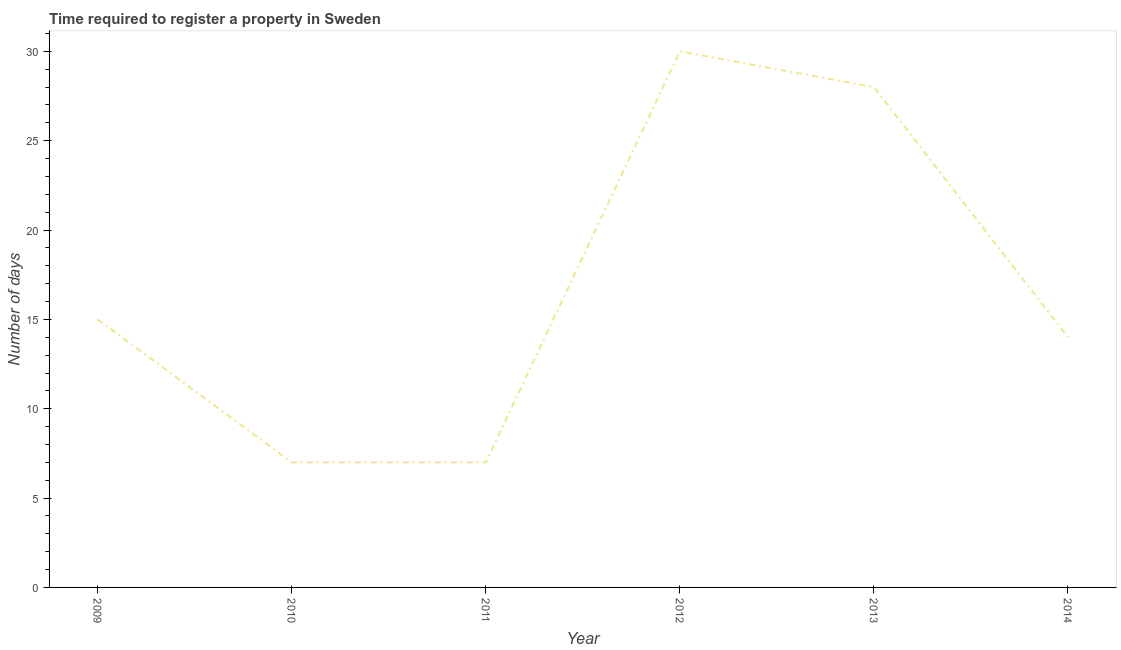What is the number of days required to register property in 2013?
Offer a very short reply. 28. Across all years, what is the maximum number of days required to register property?
Keep it short and to the point. 30. Across all years, what is the minimum number of days required to register property?
Your response must be concise. 7. What is the sum of the number of days required to register property?
Make the answer very short. 101. What is the difference between the number of days required to register property in 2011 and 2014?
Your answer should be very brief. -7. What is the average number of days required to register property per year?
Your response must be concise. 16.83. In how many years, is the number of days required to register property greater than 14 days?
Your answer should be compact. 3. Do a majority of the years between 2013 and 2012 (inclusive) have number of days required to register property greater than 26 days?
Your response must be concise. No. What is the ratio of the number of days required to register property in 2011 to that in 2012?
Provide a succinct answer. 0.23. Is the number of days required to register property in 2010 less than that in 2012?
Keep it short and to the point. Yes. Is the sum of the number of days required to register property in 2012 and 2014 greater than the maximum number of days required to register property across all years?
Ensure brevity in your answer.  Yes. What is the difference between the highest and the lowest number of days required to register property?
Provide a succinct answer. 23. Does the number of days required to register property monotonically increase over the years?
Provide a succinct answer. No. How many lines are there?
Provide a succinct answer. 1. What is the difference between two consecutive major ticks on the Y-axis?
Offer a terse response. 5. Are the values on the major ticks of Y-axis written in scientific E-notation?
Ensure brevity in your answer.  No. What is the title of the graph?
Offer a terse response. Time required to register a property in Sweden. What is the label or title of the Y-axis?
Make the answer very short. Number of days. What is the Number of days in 2009?
Offer a terse response. 15. What is the Number of days of 2010?
Your answer should be compact. 7. What is the Number of days of 2011?
Offer a very short reply. 7. What is the Number of days in 2012?
Provide a succinct answer. 30. What is the Number of days in 2014?
Keep it short and to the point. 14. What is the difference between the Number of days in 2010 and 2011?
Ensure brevity in your answer.  0. What is the difference between the Number of days in 2010 and 2012?
Your answer should be very brief. -23. What is the difference between the Number of days in 2010 and 2013?
Your answer should be very brief. -21. What is the difference between the Number of days in 2012 and 2014?
Your answer should be very brief. 16. What is the ratio of the Number of days in 2009 to that in 2010?
Give a very brief answer. 2.14. What is the ratio of the Number of days in 2009 to that in 2011?
Your response must be concise. 2.14. What is the ratio of the Number of days in 2009 to that in 2013?
Your answer should be very brief. 0.54. What is the ratio of the Number of days in 2009 to that in 2014?
Keep it short and to the point. 1.07. What is the ratio of the Number of days in 2010 to that in 2011?
Keep it short and to the point. 1. What is the ratio of the Number of days in 2010 to that in 2012?
Your answer should be very brief. 0.23. What is the ratio of the Number of days in 2010 to that in 2013?
Provide a short and direct response. 0.25. What is the ratio of the Number of days in 2010 to that in 2014?
Provide a short and direct response. 0.5. What is the ratio of the Number of days in 2011 to that in 2012?
Provide a succinct answer. 0.23. What is the ratio of the Number of days in 2011 to that in 2013?
Your response must be concise. 0.25. What is the ratio of the Number of days in 2012 to that in 2013?
Your answer should be compact. 1.07. What is the ratio of the Number of days in 2012 to that in 2014?
Provide a succinct answer. 2.14. 